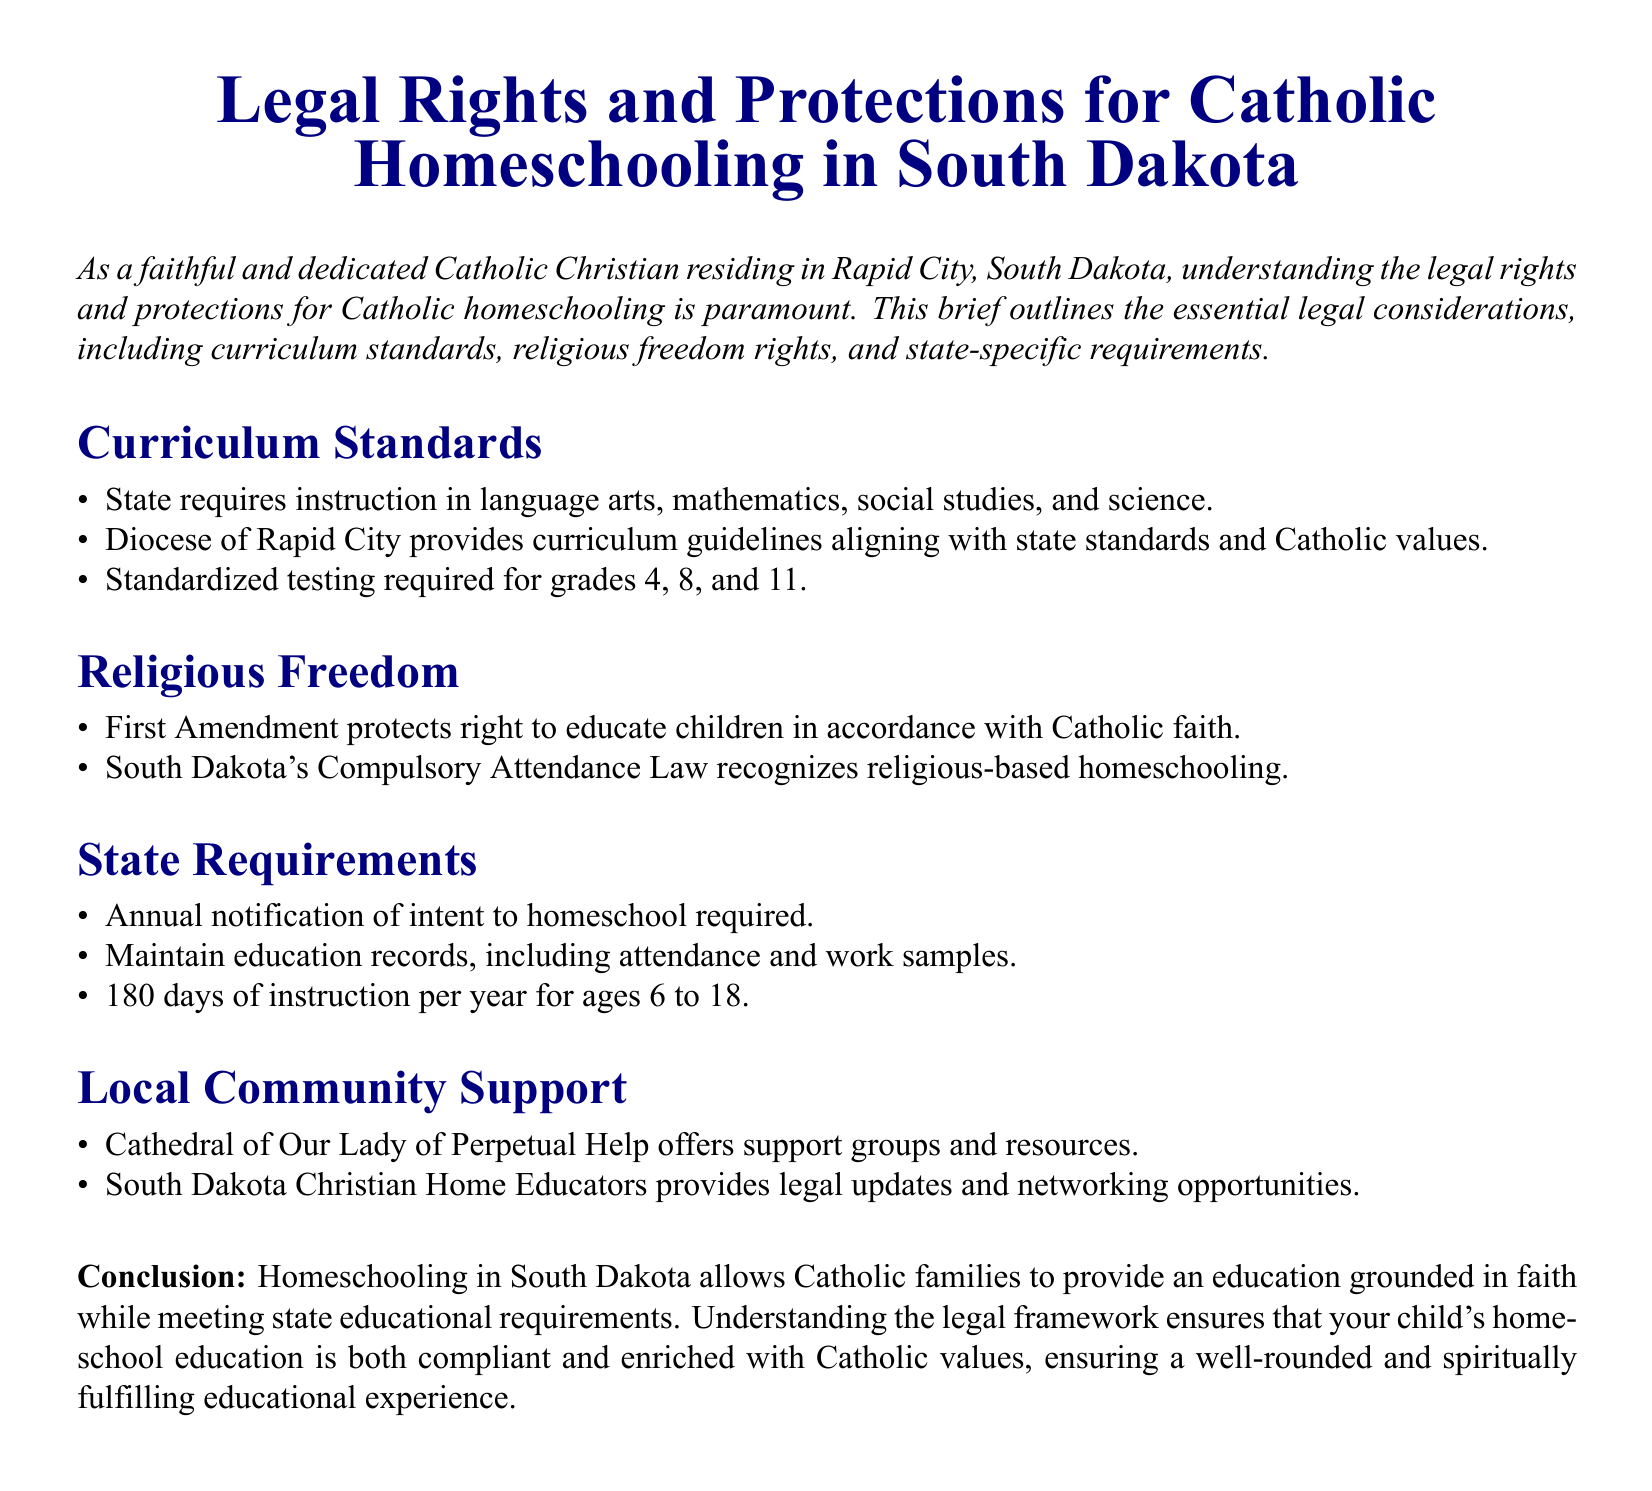What subjects must be included in homeschooling? The document lists required subjects as language arts, mathematics, social studies, and science.
Answer: language arts, mathematics, social studies, science Which grades require standardized testing? The document specifies that standardized testing is required for grades 4, 8, and 11.
Answer: 4, 8, 11 What law protects the right to educate children in accordance with Catholic faith? The document refers to the First Amendment as the law that protects this right.
Answer: First Amendment How many days of instruction are required per year? The document states that 180 days of instruction per year is required for ages 6 to 18.
Answer: 180 days What is required for families intending to homeschool? The document mentions that annual notification of intent to homeschool is required.
Answer: Annual notification How does the Diocese of Rapid City support homeschooling families? The document states that the Diocese provides curriculum guidelines aligning with state standards and Catholic values.
Answer: Curriculum guidelines Which organization offers support groups for Catholic homeschooling? The document mentions the Cathedral of Our Lady of Perpetual Help as offering support groups.
Answer: Cathedral of Our Lady of Perpetual Help What must be maintained as part of state requirements? The document indicates that education records, including attendance and work samples, must be maintained.
Answer: Education records What is the primary purpose of this legal brief? The document outlines that the primary purpose is to explain legal rights and protections for Catholic homeschooling.
Answer: Explain legal rights and protections 